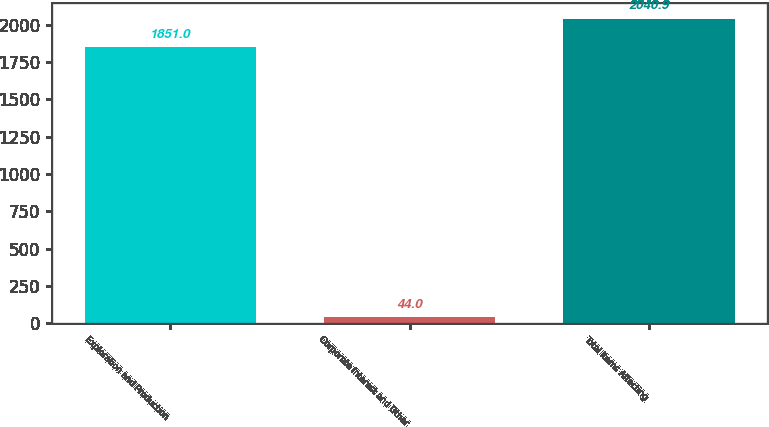<chart> <loc_0><loc_0><loc_500><loc_500><bar_chart><fcel>Exploration and Production<fcel>Corporate Interest and Other<fcel>Total Items Affecting<nl><fcel>1851<fcel>44<fcel>2040.9<nl></chart> 